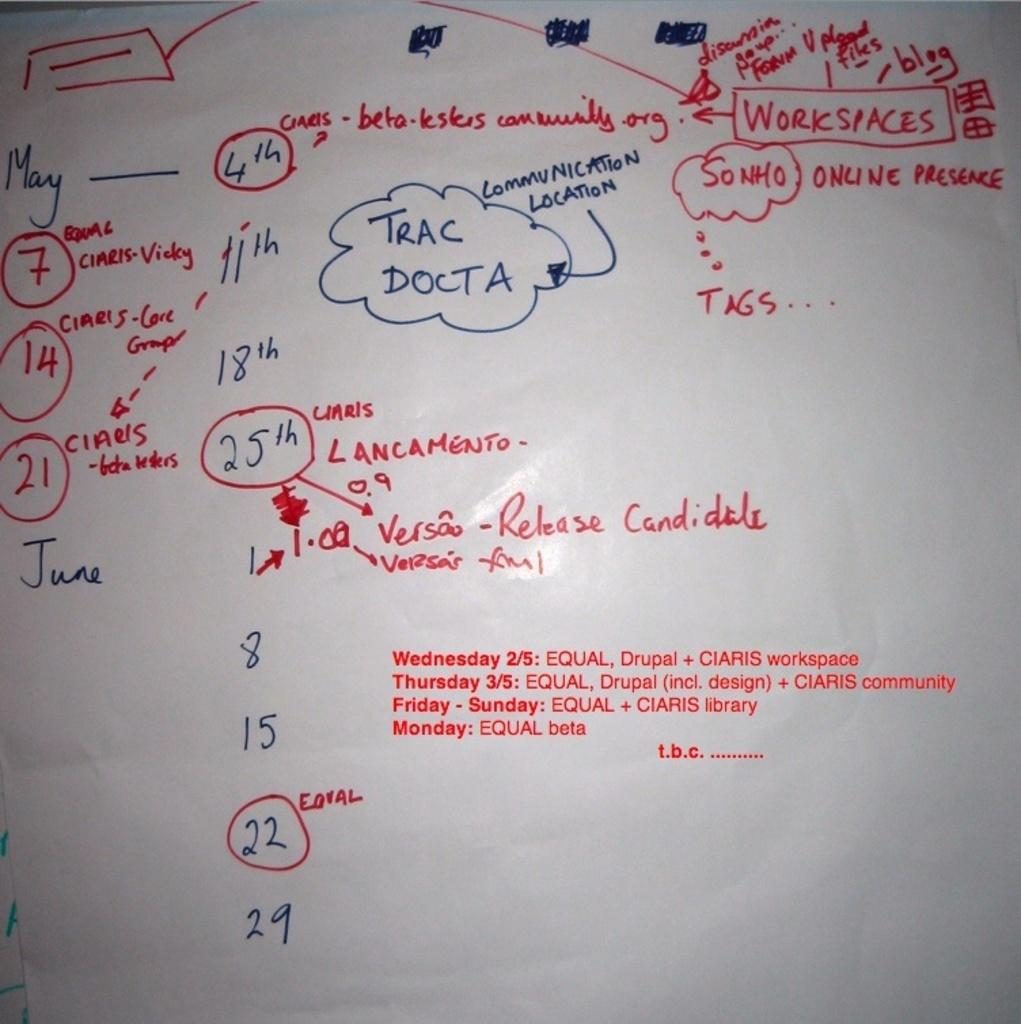<image>
Offer a succinct explanation of the picture presented. a whiteboard with numbers like 7 and 22 and words Trac Docta 